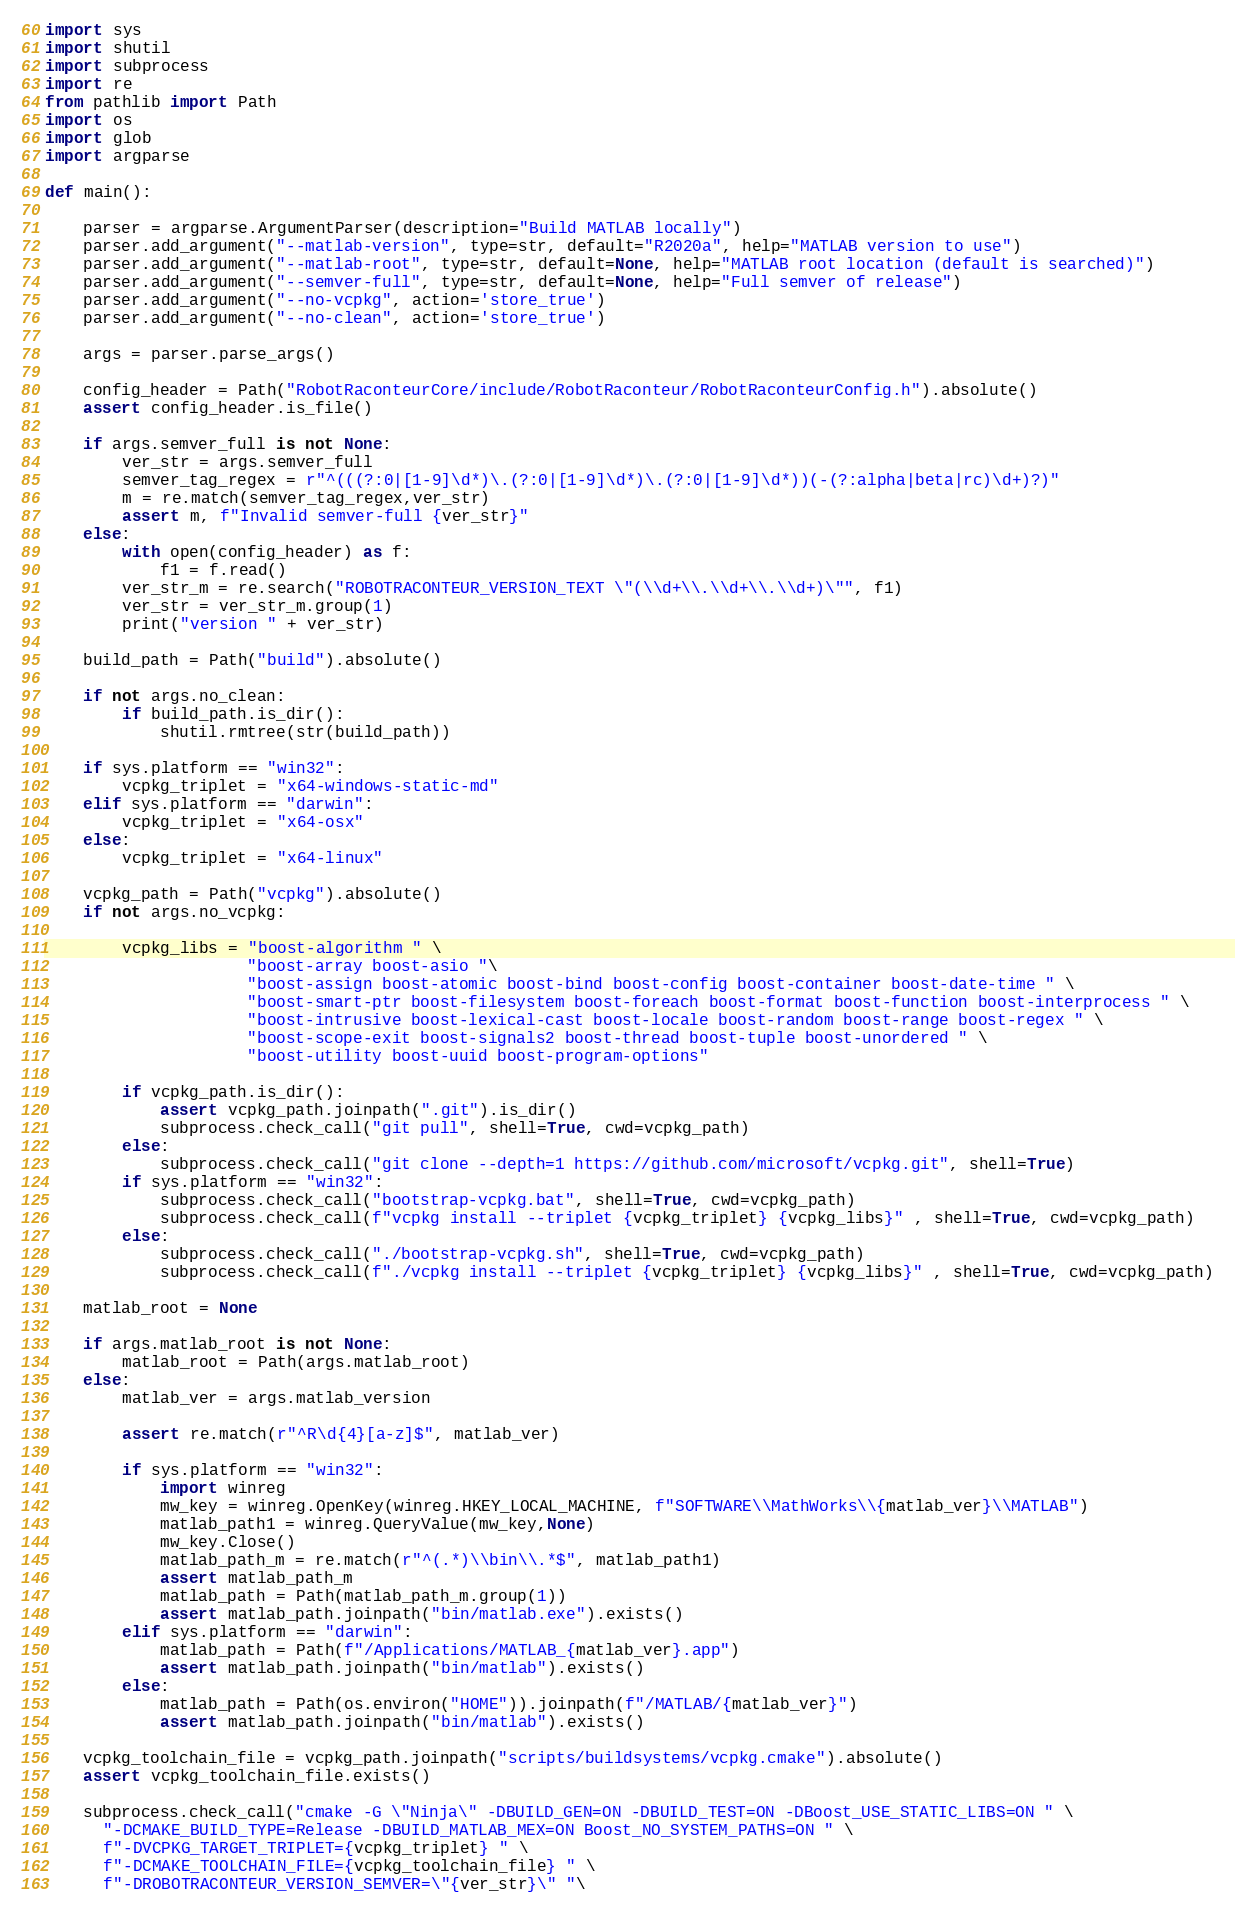Convert code to text. <code><loc_0><loc_0><loc_500><loc_500><_Python_>import sys
import shutil
import subprocess
import re
from pathlib import Path
import os
import glob
import argparse

def main():

    parser = argparse.ArgumentParser(description="Build MATLAB locally")
    parser.add_argument("--matlab-version", type=str, default="R2020a", help="MATLAB version to use")
    parser.add_argument("--matlab-root", type=str, default=None, help="MATLAB root location (default is searched)")
    parser.add_argument("--semver-full", type=str, default=None, help="Full semver of release")
    parser.add_argument("--no-vcpkg", action='store_true')
    parser.add_argument("--no-clean", action='store_true')

    args = parser.parse_args()

    config_header = Path("RobotRaconteurCore/include/RobotRaconteur/RobotRaconteurConfig.h").absolute()
    assert config_header.is_file()

    if args.semver_full is not None:
        ver_str = args.semver_full
        semver_tag_regex = r"^(((?:0|[1-9]\d*)\.(?:0|[1-9]\d*)\.(?:0|[1-9]\d*))(-(?:alpha|beta|rc)\d+)?)"
        m = re.match(semver_tag_regex,ver_str)
        assert m, f"Invalid semver-full {ver_str}"
    else:
        with open(config_header) as f:
            f1 = f.read()
        ver_str_m = re.search("ROBOTRACONTEUR_VERSION_TEXT \"(\\d+\\.\\d+\\.\\d+)\"", f1)
        ver_str = ver_str_m.group(1)
        print("version " + ver_str)

    build_path = Path("build").absolute()

    if not args.no_clean:
        if build_path.is_dir():
            shutil.rmtree(str(build_path))

    if sys.platform == "win32":
        vcpkg_triplet = "x64-windows-static-md"
    elif sys.platform == "darwin":
        vcpkg_triplet = "x64-osx"
    else:
        vcpkg_triplet = "x64-linux"

    vcpkg_path = Path("vcpkg").absolute()
    if not args.no_vcpkg:        

        vcpkg_libs = "boost-algorithm " \
                     "boost-array boost-asio "\
                     "boost-assign boost-atomic boost-bind boost-config boost-container boost-date-time " \
                     "boost-smart-ptr boost-filesystem boost-foreach boost-format boost-function boost-interprocess " \
                     "boost-intrusive boost-lexical-cast boost-locale boost-random boost-range boost-regex " \
                     "boost-scope-exit boost-signals2 boost-thread boost-tuple boost-unordered " \
                     "boost-utility boost-uuid boost-program-options"

        if vcpkg_path.is_dir():
            assert vcpkg_path.joinpath(".git").is_dir()
            subprocess.check_call("git pull", shell=True, cwd=vcpkg_path)
        else:
            subprocess.check_call("git clone --depth=1 https://github.com/microsoft/vcpkg.git", shell=True)
        if sys.platform == "win32":
            subprocess.check_call("bootstrap-vcpkg.bat", shell=True, cwd=vcpkg_path)
            subprocess.check_call(f"vcpkg install --triplet {vcpkg_triplet} {vcpkg_libs}" , shell=True, cwd=vcpkg_path)
        else:
            subprocess.check_call("./bootstrap-vcpkg.sh", shell=True, cwd=vcpkg_path)
            subprocess.check_call(f"./vcpkg install --triplet {vcpkg_triplet} {vcpkg_libs}" , shell=True, cwd=vcpkg_path)

    matlab_root = None

    if args.matlab_root is not None:
        matlab_root = Path(args.matlab_root)
    else:
        matlab_ver = args.matlab_version

        assert re.match(r"^R\d{4}[a-z]$", matlab_ver)

        if sys.platform == "win32":
            import winreg
            mw_key = winreg.OpenKey(winreg.HKEY_LOCAL_MACHINE, f"SOFTWARE\\MathWorks\\{matlab_ver}\\MATLAB")
            matlab_path1 = winreg.QueryValue(mw_key,None)
            mw_key.Close()
            matlab_path_m = re.match(r"^(.*)\\bin\\.*$", matlab_path1)
            assert matlab_path_m
            matlab_path = Path(matlab_path_m.group(1))
            assert matlab_path.joinpath("bin/matlab.exe").exists()
        elif sys.platform == "darwin":
            matlab_path = Path(f"/Applications/MATLAB_{matlab_ver}.app")
            assert matlab_path.joinpath("bin/matlab").exists()
        else:
            matlab_path = Path(os.environ("HOME")).joinpath(f"/MATLAB/{matlab_ver}")
            assert matlab_path.joinpath("bin/matlab").exists()

    vcpkg_toolchain_file = vcpkg_path.joinpath("scripts/buildsystems/vcpkg.cmake").absolute()
    assert vcpkg_toolchain_file.exists()
    
    subprocess.check_call("cmake -G \"Ninja\" -DBUILD_GEN=ON -DBUILD_TEST=ON -DBoost_USE_STATIC_LIBS=ON " \
      "-DCMAKE_BUILD_TYPE=Release -DBUILD_MATLAB_MEX=ON Boost_NO_SYSTEM_PATHS=ON " \
      f"-DVCPKG_TARGET_TRIPLET={vcpkg_triplet} " \
      f"-DCMAKE_TOOLCHAIN_FILE={vcpkg_toolchain_file} " \
      f"-DROBOTRACONTEUR_VERSION_SEMVER=\"{ver_str}\" "\</code> 